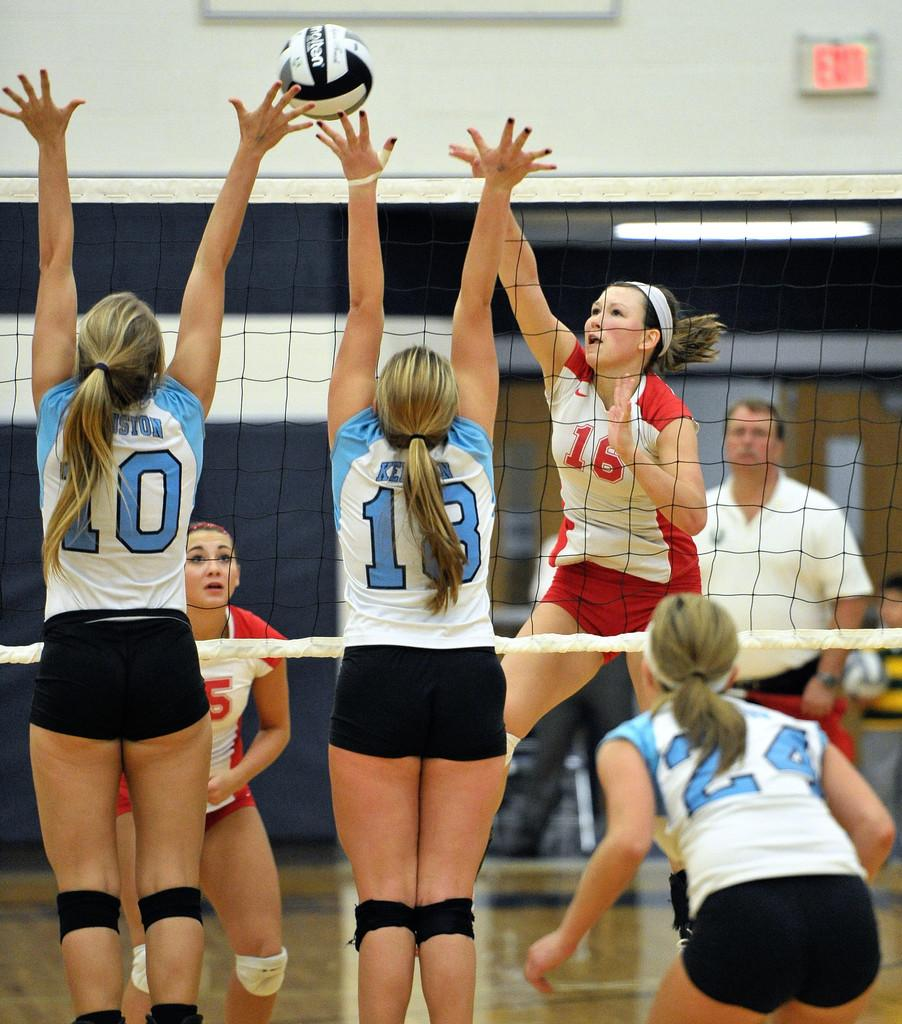<image>
Relay a brief, clear account of the picture shown. ladies volleyball game with numbers 10, 18, and 24 wearing blue, black and white 